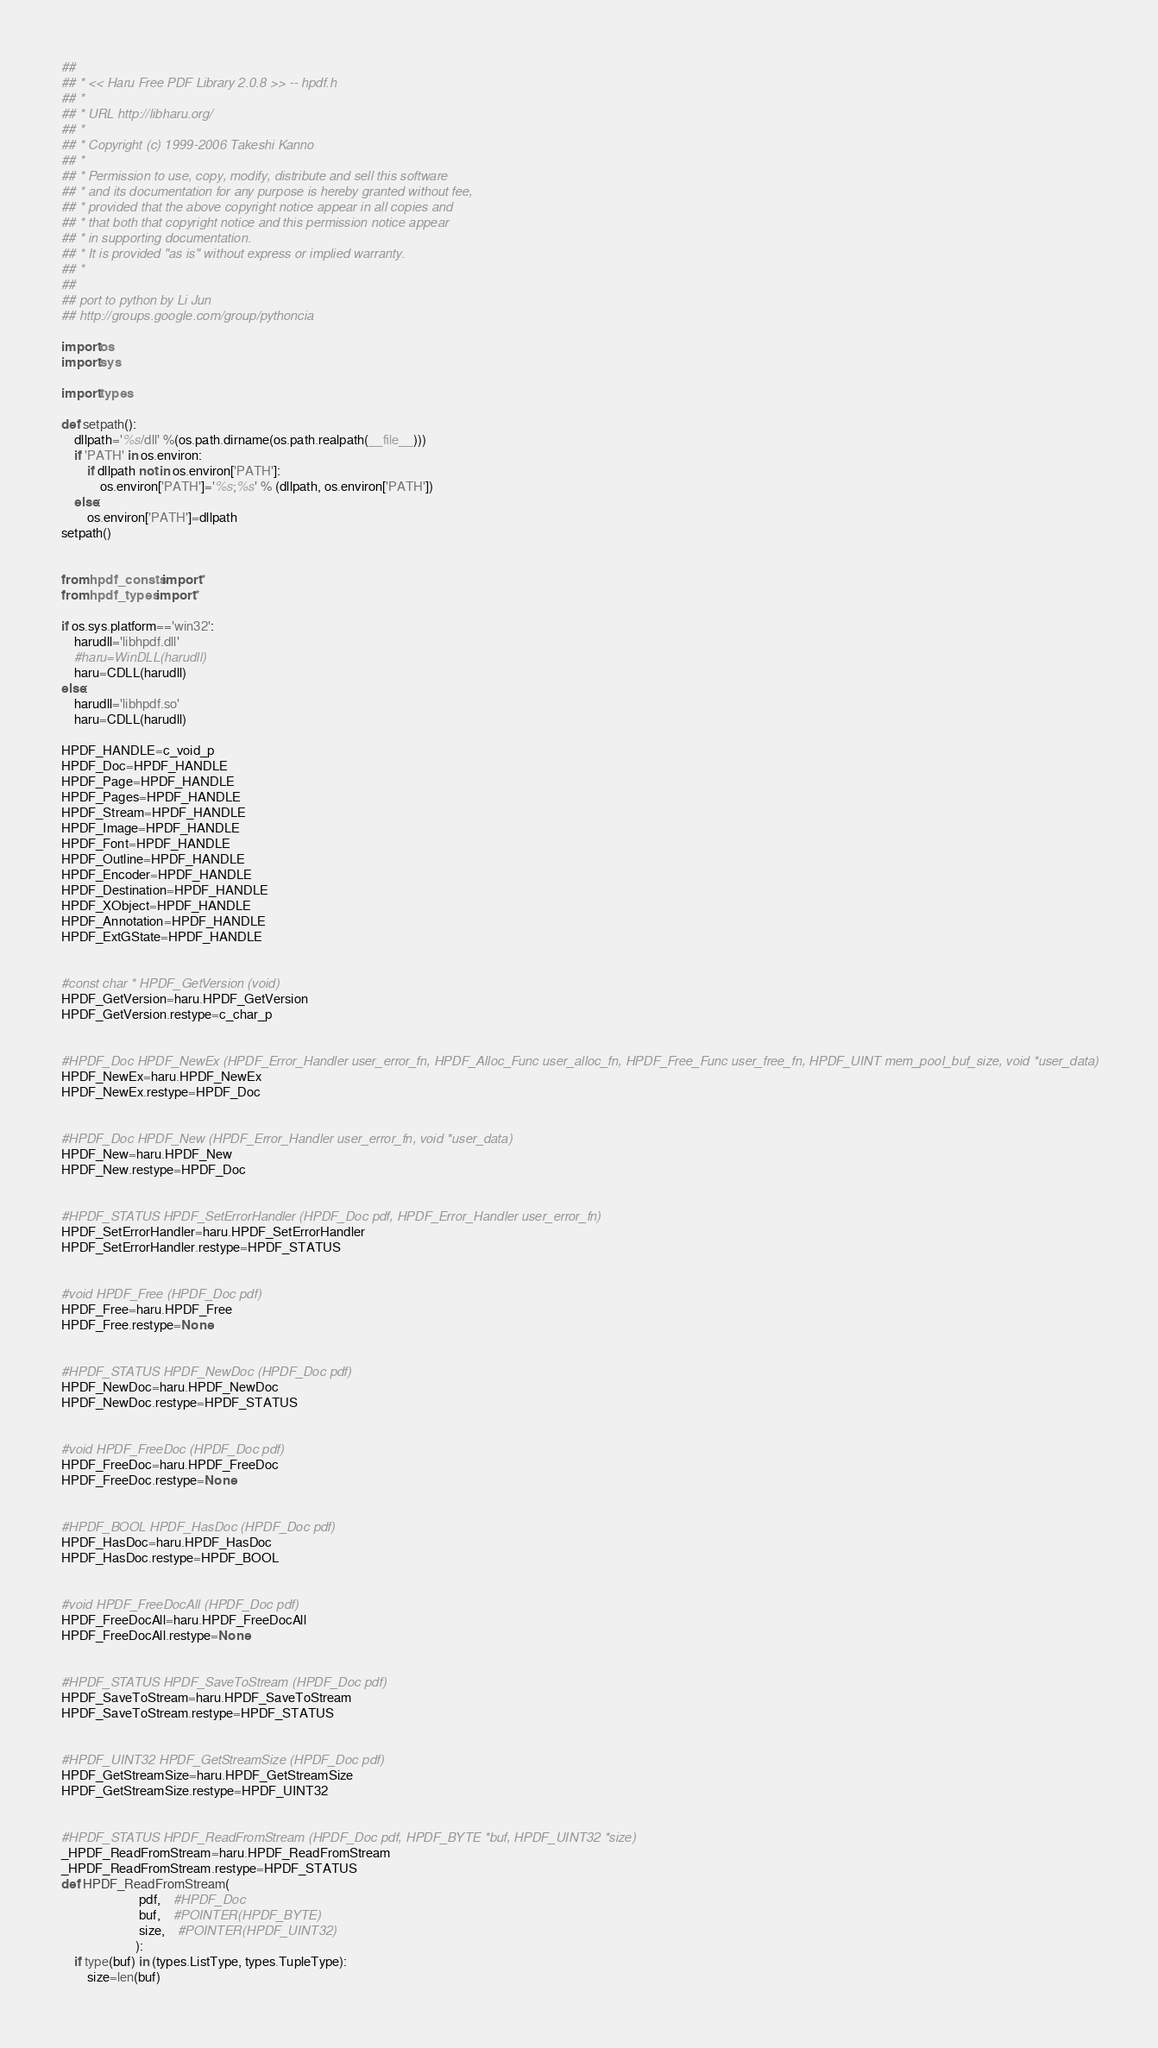<code> <loc_0><loc_0><loc_500><loc_500><_Python_>##
## * << Haru Free PDF Library 2.0.8 >> -- hpdf.h
## *
## * URL http://libharu.org/
## *
## * Copyright (c) 1999-2006 Takeshi Kanno
## *
## * Permission to use, copy, modify, distribute and sell this software
## * and its documentation for any purpose is hereby granted without fee,
## * provided that the above copyright notice appear in all copies and
## * that both that copyright notice and this permission notice appear
## * in supporting documentation.
## * It is provided "as is" without express or implied warranty.
## *
##
## port to python by Li Jun
## http://groups.google.com/group/pythoncia

import os
import sys

import types

def setpath():
    dllpath='%s/dll' %(os.path.dirname(os.path.realpath(__file__)))
    if 'PATH' in os.environ:
        if dllpath not in os.environ['PATH']:
            os.environ['PATH']='%s;%s' % (dllpath, os.environ['PATH'])
    else:
        os.environ['PATH']=dllpath
setpath()


from hpdf_consts import *
from hpdf_types import *

if os.sys.platform=='win32':
    harudll='libhpdf.dll'
    #haru=WinDLL(harudll)
    haru=CDLL(harudll)
else:
    harudll='libhpdf.so'
    haru=CDLL(harudll)

HPDF_HANDLE=c_void_p
HPDF_Doc=HPDF_HANDLE
HPDF_Page=HPDF_HANDLE
HPDF_Pages=HPDF_HANDLE
HPDF_Stream=HPDF_HANDLE
HPDF_Image=HPDF_HANDLE
HPDF_Font=HPDF_HANDLE
HPDF_Outline=HPDF_HANDLE
HPDF_Encoder=HPDF_HANDLE
HPDF_Destination=HPDF_HANDLE
HPDF_XObject=HPDF_HANDLE
HPDF_Annotation=HPDF_HANDLE
HPDF_ExtGState=HPDF_HANDLE


#const char * HPDF_GetVersion (void)
HPDF_GetVersion=haru.HPDF_GetVersion
HPDF_GetVersion.restype=c_char_p


#HPDF_Doc HPDF_NewEx (HPDF_Error_Handler user_error_fn, HPDF_Alloc_Func user_alloc_fn, HPDF_Free_Func user_free_fn, HPDF_UINT mem_pool_buf_size, void *user_data)
HPDF_NewEx=haru.HPDF_NewEx
HPDF_NewEx.restype=HPDF_Doc


#HPDF_Doc HPDF_New (HPDF_Error_Handler user_error_fn, void *user_data)
HPDF_New=haru.HPDF_New
HPDF_New.restype=HPDF_Doc


#HPDF_STATUS HPDF_SetErrorHandler (HPDF_Doc pdf, HPDF_Error_Handler user_error_fn)
HPDF_SetErrorHandler=haru.HPDF_SetErrorHandler
HPDF_SetErrorHandler.restype=HPDF_STATUS


#void HPDF_Free (HPDF_Doc pdf)
HPDF_Free=haru.HPDF_Free
HPDF_Free.restype=None


#HPDF_STATUS HPDF_NewDoc (HPDF_Doc pdf)
HPDF_NewDoc=haru.HPDF_NewDoc
HPDF_NewDoc.restype=HPDF_STATUS


#void HPDF_FreeDoc (HPDF_Doc pdf)
HPDF_FreeDoc=haru.HPDF_FreeDoc
HPDF_FreeDoc.restype=None


#HPDF_BOOL HPDF_HasDoc (HPDF_Doc pdf)
HPDF_HasDoc=haru.HPDF_HasDoc
HPDF_HasDoc.restype=HPDF_BOOL


#void HPDF_FreeDocAll (HPDF_Doc pdf)
HPDF_FreeDocAll=haru.HPDF_FreeDocAll
HPDF_FreeDocAll.restype=None


#HPDF_STATUS HPDF_SaveToStream (HPDF_Doc pdf)
HPDF_SaveToStream=haru.HPDF_SaveToStream
HPDF_SaveToStream.restype=HPDF_STATUS


#HPDF_UINT32 HPDF_GetStreamSize (HPDF_Doc pdf)
HPDF_GetStreamSize=haru.HPDF_GetStreamSize
HPDF_GetStreamSize.restype=HPDF_UINT32


#HPDF_STATUS HPDF_ReadFromStream (HPDF_Doc pdf, HPDF_BYTE *buf, HPDF_UINT32 *size)
_HPDF_ReadFromStream=haru.HPDF_ReadFromStream
_HPDF_ReadFromStream.restype=HPDF_STATUS
def HPDF_ReadFromStream(
                        pdf,    #HPDF_Doc
                        buf,    #POINTER(HPDF_BYTE)
                        size,    #POINTER(HPDF_UINT32)
                       ):
    if type(buf) in (types.ListType, types.TupleType):
        size=len(buf)</code> 